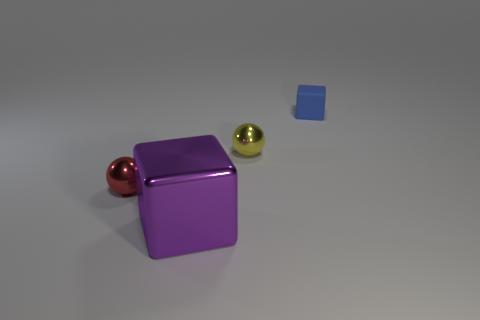Add 1 purple things. How many objects exist? 5 Subtract 1 balls. How many balls are left? 1 Subtract all blue spheres. Subtract all green cubes. How many spheres are left? 2 Add 1 small red rubber things. How many small red rubber things exist? 1 Subtract 1 red balls. How many objects are left? 3 Subtract all brown cylinders. How many cyan cubes are left? 0 Subtract all rubber cubes. Subtract all purple cylinders. How many objects are left? 3 Add 1 purple things. How many purple things are left? 2 